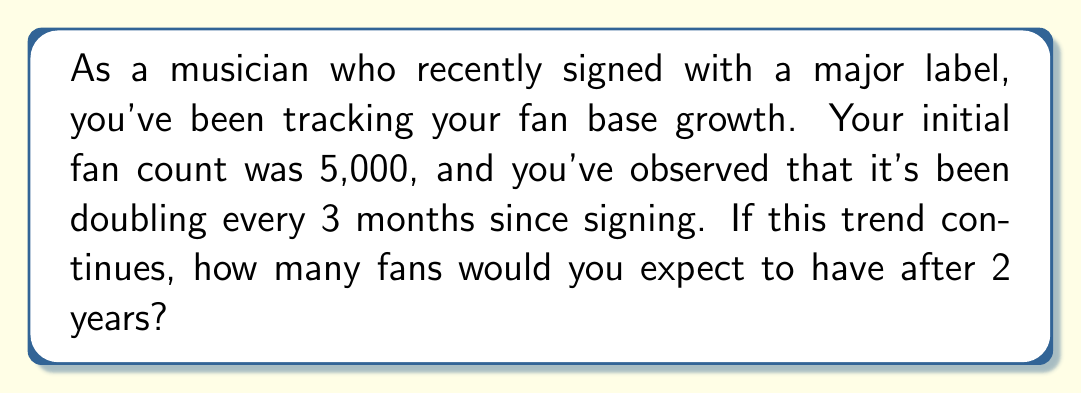Could you help me with this problem? Let's approach this step-by-step:

1) First, we need to identify the components of our exponential function:
   - Initial value (a): 5,000 fans
   - Growth rate (r): doubles every 3 months, so $2^{\frac{1}{3}}$ per month
   - Time (t): 2 years = 24 months

2) The exponential function for fan growth is:
   $$ f(t) = a(1+r)^t $$

3) In this case:
   $$ f(t) = 5000(2^{\frac{1}{3}})^t $$

4) We need to calculate $(2^{\frac{1}{3}})^{24}$:
   $$ (2^{\frac{1}{3}})^{24} = 2^8 = 256 $$

5) Now, we can plug this into our function:
   $$ f(24) = 5000 \cdot 256 = 1,280,000 $$

Therefore, after 2 years (24 months), you would expect to have 1,280,000 fans.
Answer: 1,280,000 fans 